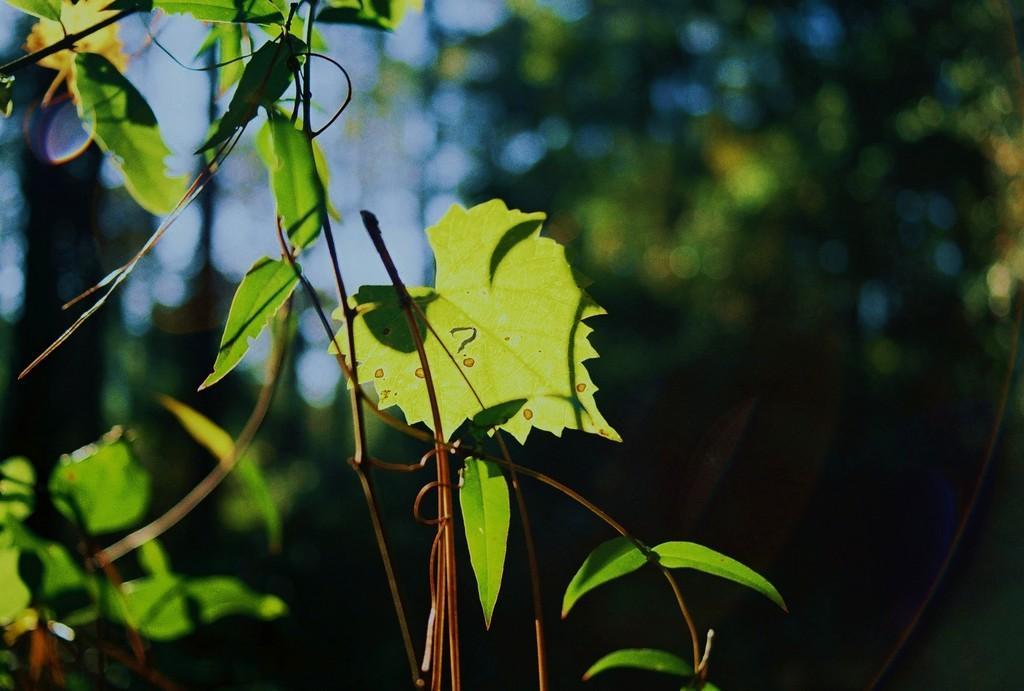How would you summarize this image in a sentence or two? In this image, we can see green leaves with stems. Background there is a blur view. 